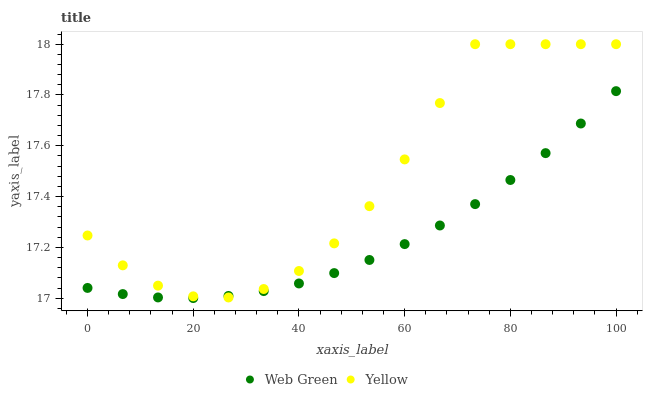Does Web Green have the minimum area under the curve?
Answer yes or no. Yes. Does Yellow have the maximum area under the curve?
Answer yes or no. Yes. Does Web Green have the maximum area under the curve?
Answer yes or no. No. Is Web Green the smoothest?
Answer yes or no. Yes. Is Yellow the roughest?
Answer yes or no. Yes. Is Web Green the roughest?
Answer yes or no. No. Does Web Green have the lowest value?
Answer yes or no. Yes. Does Yellow have the highest value?
Answer yes or no. Yes. Does Web Green have the highest value?
Answer yes or no. No. Does Yellow intersect Web Green?
Answer yes or no. Yes. Is Yellow less than Web Green?
Answer yes or no. No. Is Yellow greater than Web Green?
Answer yes or no. No. 